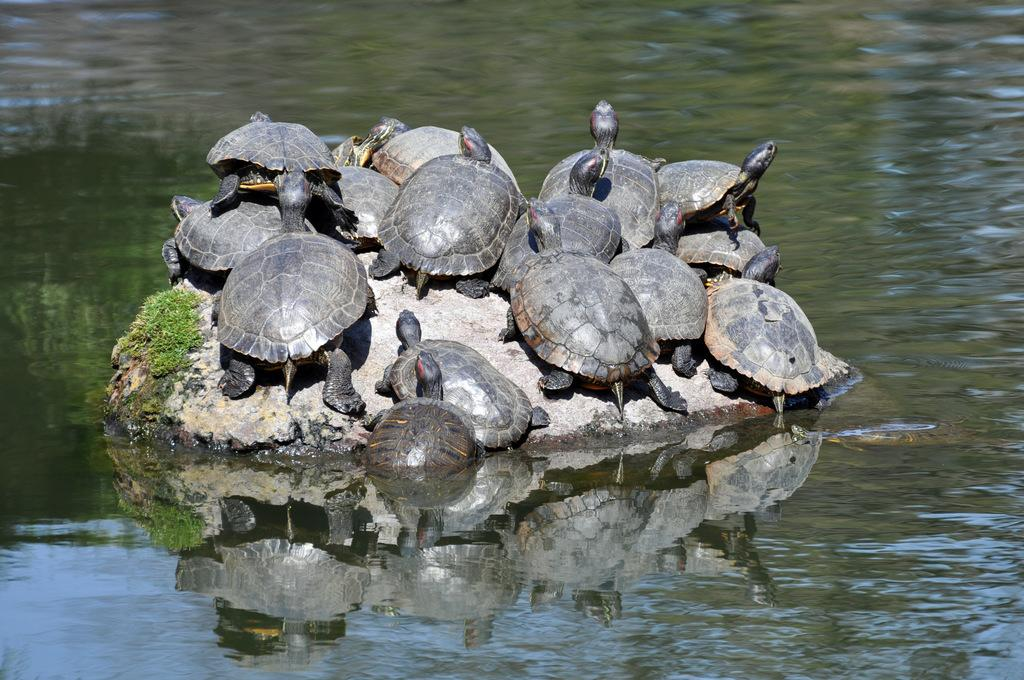What type of animals are in the image? There are tortoises in the image. What surface are the tortoises on? The tortoises are on a rock. What are the tortoises eating? The tortoises are having grass. What is the environment like around the rock? The rock is surrounded by water. What type of vegetable is growing on the tortoises in the image? There are no vegetables growing on the tortoises in the image; they are eating grass. 